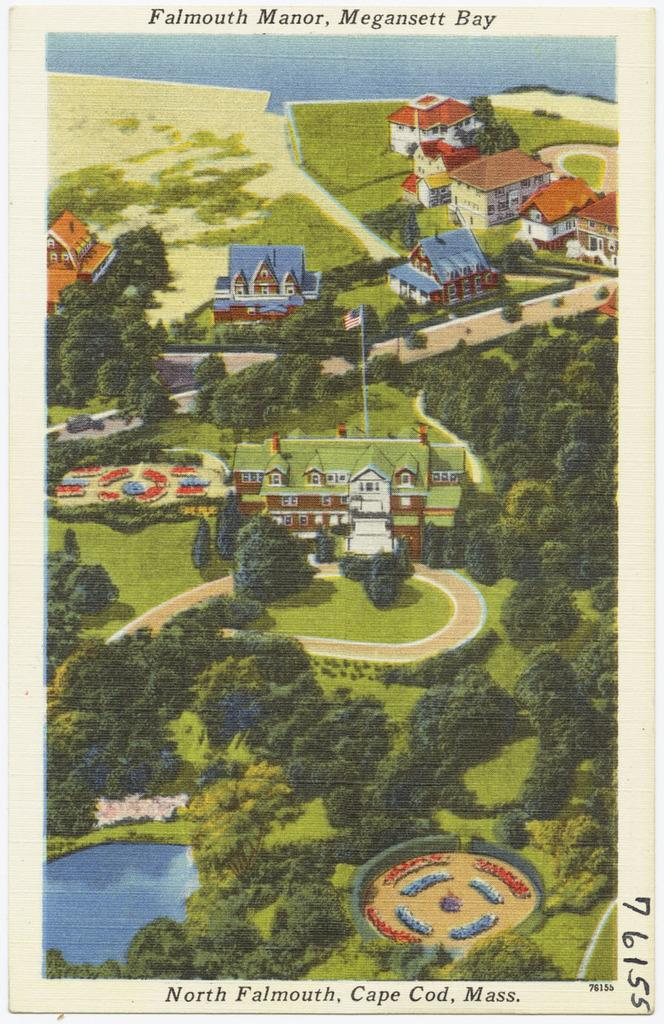<image>
Share a concise interpretation of the image provided. A postcard of North Falmouth in Cape Cod is numbered 76155. 